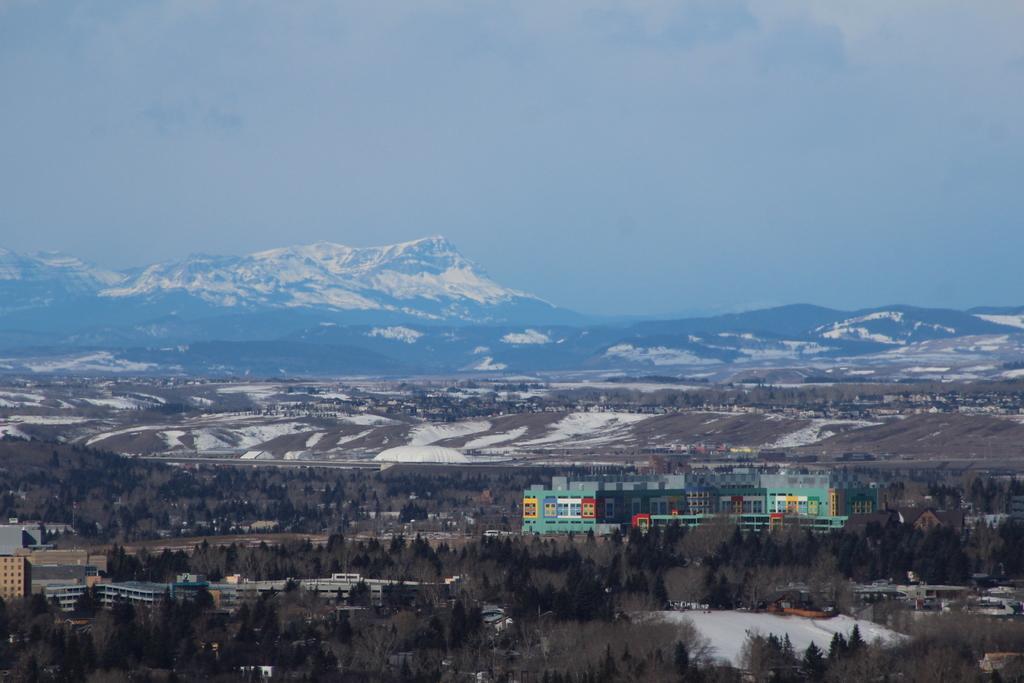In one or two sentences, can you explain what this image depicts? There are many trees and buildings. Also there is snow. In the background there are hills and sky. 